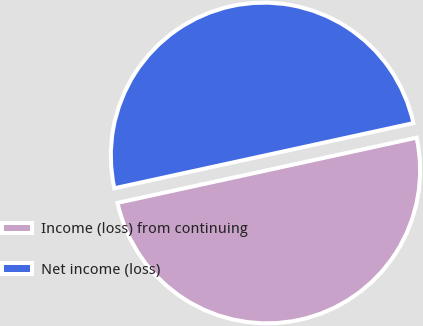<chart> <loc_0><loc_0><loc_500><loc_500><pie_chart><fcel>Income (loss) from continuing<fcel>Net income (loss)<nl><fcel>50.0%<fcel>50.0%<nl></chart> 